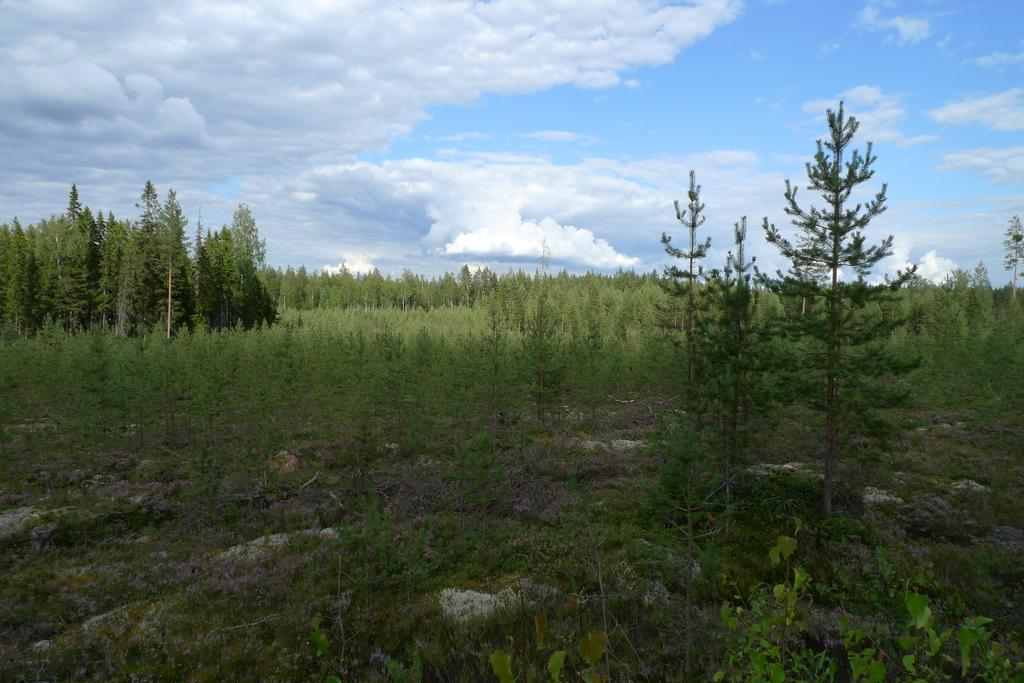What type of surface is visible in the image? There is a ground in the image. What type of vegetation can be seen in the image? There are plants and trees in the image. What is visible at the top of the image? The sky is visible at the top of the image. How many cacti are present in the image? There is no mention of cacti in the provided facts, so it cannot be determined from the image. What type of furniture is visible in the image? There is no furniture, such as chairs, mentioned or visible in the image. 